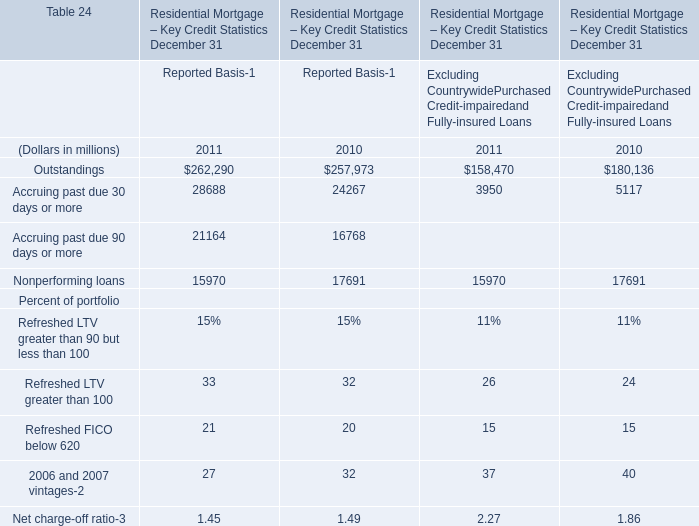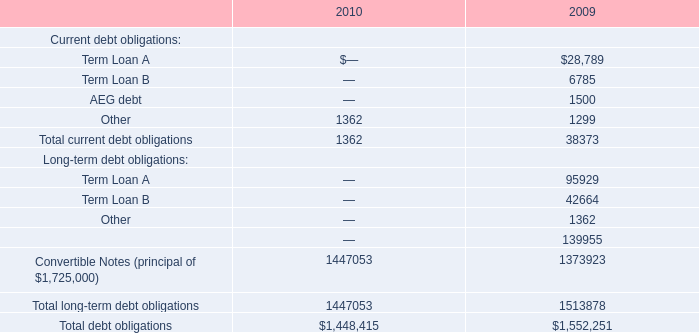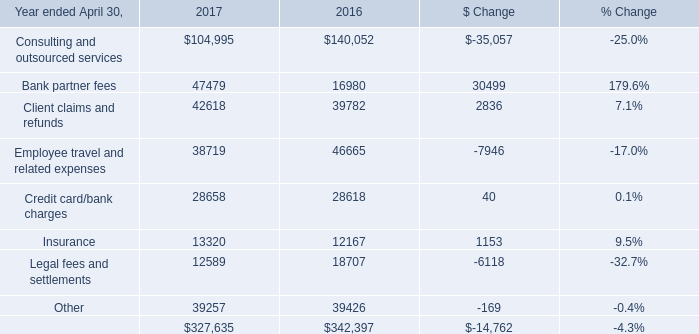what was the percentage increase in the shares of common stock of 
Computations: ((65005 - 36836) / 36836)
Answer: 0.76471. 